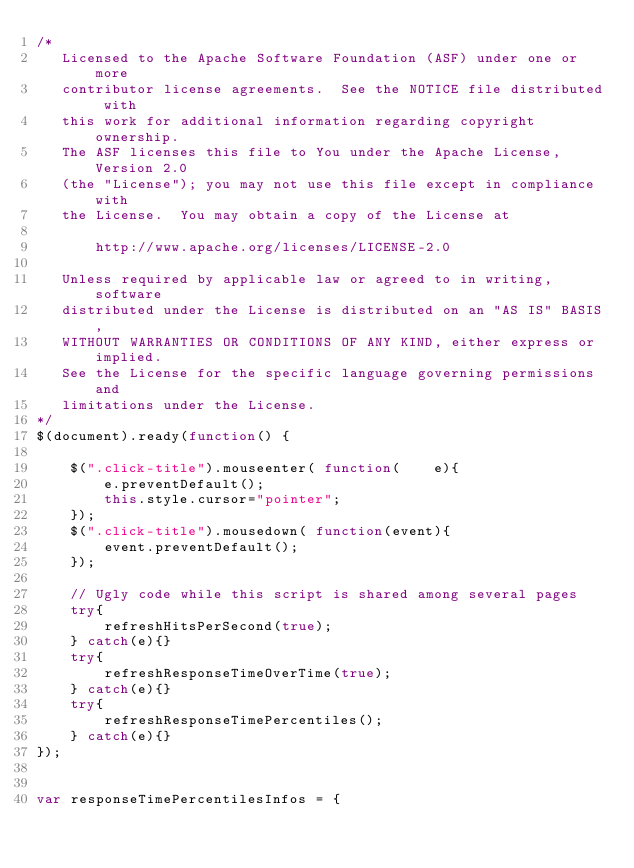<code> <loc_0><loc_0><loc_500><loc_500><_JavaScript_>/*
   Licensed to the Apache Software Foundation (ASF) under one or more
   contributor license agreements.  See the NOTICE file distributed with
   this work for additional information regarding copyright ownership.
   The ASF licenses this file to You under the Apache License, Version 2.0
   (the "License"); you may not use this file except in compliance with
   the License.  You may obtain a copy of the License at

       http://www.apache.org/licenses/LICENSE-2.0

   Unless required by applicable law or agreed to in writing, software
   distributed under the License is distributed on an "AS IS" BASIS,
   WITHOUT WARRANTIES OR CONDITIONS OF ANY KIND, either express or implied.
   See the License for the specific language governing permissions and
   limitations under the License.
*/
$(document).ready(function() {

    $(".click-title").mouseenter( function(    e){
        e.preventDefault();
        this.style.cursor="pointer";
    });
    $(".click-title").mousedown( function(event){
        event.preventDefault();
    });

    // Ugly code while this script is shared among several pages
    try{
        refreshHitsPerSecond(true);
    } catch(e){}
    try{
        refreshResponseTimeOverTime(true);
    } catch(e){}
    try{
        refreshResponseTimePercentiles();
    } catch(e){}
});


var responseTimePercentilesInfos = {</code> 